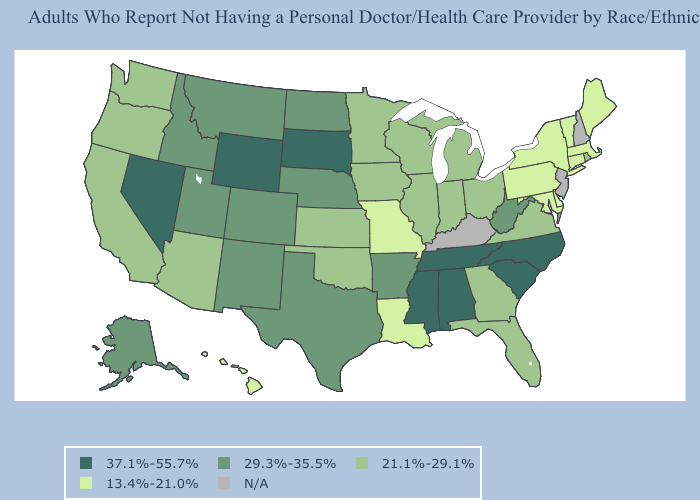Among the states that border Oregon , which have the highest value?
Concise answer only. Nevada. Among the states that border Maryland , does Virginia have the lowest value?
Keep it brief. No. What is the value of Louisiana?
Give a very brief answer. 13.4%-21.0%. Among the states that border North Carolina , does Tennessee have the lowest value?
Write a very short answer. No. Among the states that border Georgia , does Florida have the lowest value?
Quick response, please. Yes. Name the states that have a value in the range 13.4%-21.0%?
Short answer required. Connecticut, Delaware, Hawaii, Louisiana, Maine, Maryland, Massachusetts, Missouri, New York, Pennsylvania, Vermont. What is the lowest value in the West?
Concise answer only. 13.4%-21.0%. What is the lowest value in the USA?
Short answer required. 13.4%-21.0%. Among the states that border West Virginia , which have the lowest value?
Keep it brief. Maryland, Pennsylvania. What is the value of Oklahoma?
Keep it brief. 21.1%-29.1%. What is the lowest value in the South?
Short answer required. 13.4%-21.0%. Name the states that have a value in the range 29.3%-35.5%?
Quick response, please. Alaska, Arkansas, Colorado, Idaho, Montana, Nebraska, New Mexico, North Dakota, Texas, Utah, West Virginia. 